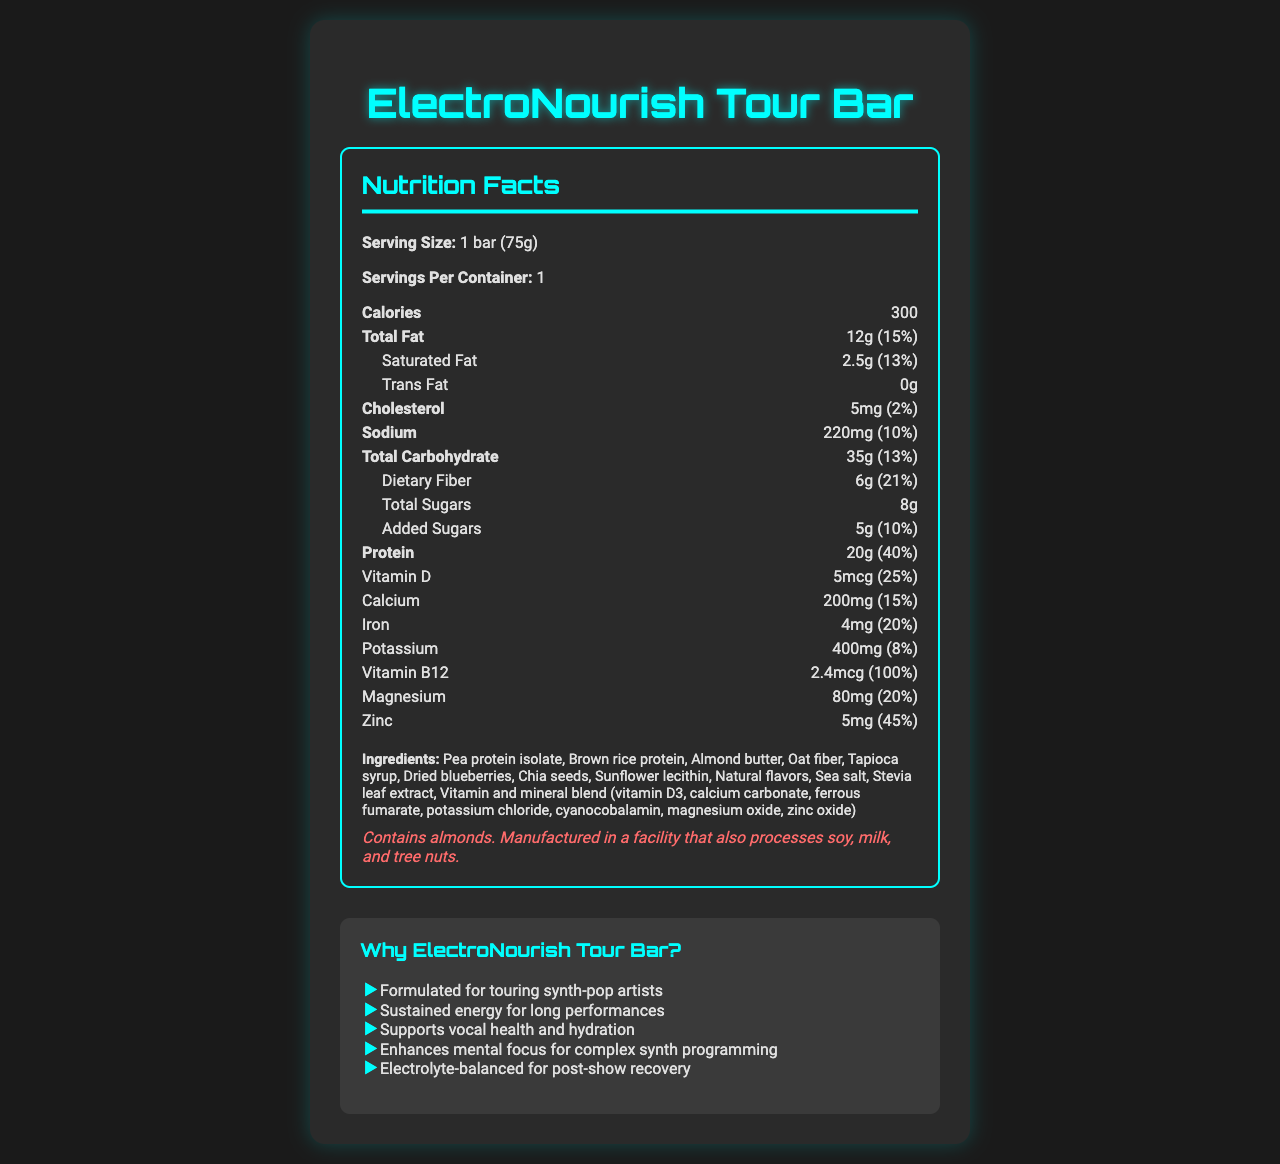what is the name of the product? The product name is clearly stated at the top of the document.
Answer: ElectroNourish Tour Bar what is the serving size for the ElectroNourish Tour Bar? The serving size is specified as "1 bar (75g)" in the document.
Answer: 1 bar (75g) how many calories are in one bar? The document lists the calories for one bar as 300.
Answer: 300 what is the main source of protein in the ElectroNourish Tour Bar? The ingredients list highlights Pea protein isolate and Brown rice protein as the main sources of protein.
Answer: Pea protein isolate and Brown rice protein how much protein does the ElectroNourish Tour Bar provide? The nutrition facts indicate that the bar provides 20g of protein, which accounts for 40% of the daily value.
Answer: 20g, 40% of daily value how much dietary fiber is in each serving? The bar contains 6g of dietary fiber, which is 21% of the daily value.
Answer: 6g, 21% of daily value what allergens are mentioned on the label? The allergen information states that the product contains almonds and is processed in a facility that also handles soy, milk, and tree nuts.
Answer: Contains almonds. Manufactured in a facility that also processes soy, milk, and tree nuts. which vitamin is present in the highest percentage of daily value? The document shows that Vitamin B12 is present at 100% of the daily value.
Answer: Vitamin B12, 100% of daily value how much sodium is in the product? The nutrition facts indicate that the bar contains 220mg of sodium, which is 10% of the daily value.
Answer: 220mg, 10% of daily value which ingredient appears first in the list? The first ingredient listed is Pea protein isolate.
Answer: Pea protein isolate which of the following claims is NOT made about the ElectroNourish Tour Bar? A. Supports vocal health B. Enhances weight loss C. Sustained energy for long performances The document lists claims about supporting vocal health and sustained energy, but it does not claim to enhance weight loss.
Answer: B how much added sugar does the bar contain? A. 2g B. 5g C. 8g D. 10g The added sugars amount is 5g as noted in the nutrition facts.
Answer: B is the ElectroNourish Tour Bar suitable for vegans? The document does not provide enough information to determine if the product is vegan-friendly.
Answer: Cannot be determined does the document provide information about electrolytes? The marketing claims mention that the product is electrolyte-balanced for post-show recovery, indicating information about electrolytes.
Answer: Yes summarize the main idea of the document. The document focuses on the detailed nutritional information of the ElectroNourish Tour Bar, emphasizing its benefits for touring artists through its composition and marketing claims.
Answer: The ElectroNourish Tour Bar is a nutrient-dense meal replacement bar specifically formulated for touring synth-pop artists. It provides detailed nutrition facts, highlighting its high protein and fiber content, as well as essential vitamins and minerals. The bar supports sustained energy, vocal health, mental focus, and post-show recovery with a balanced electrolyte composition. 